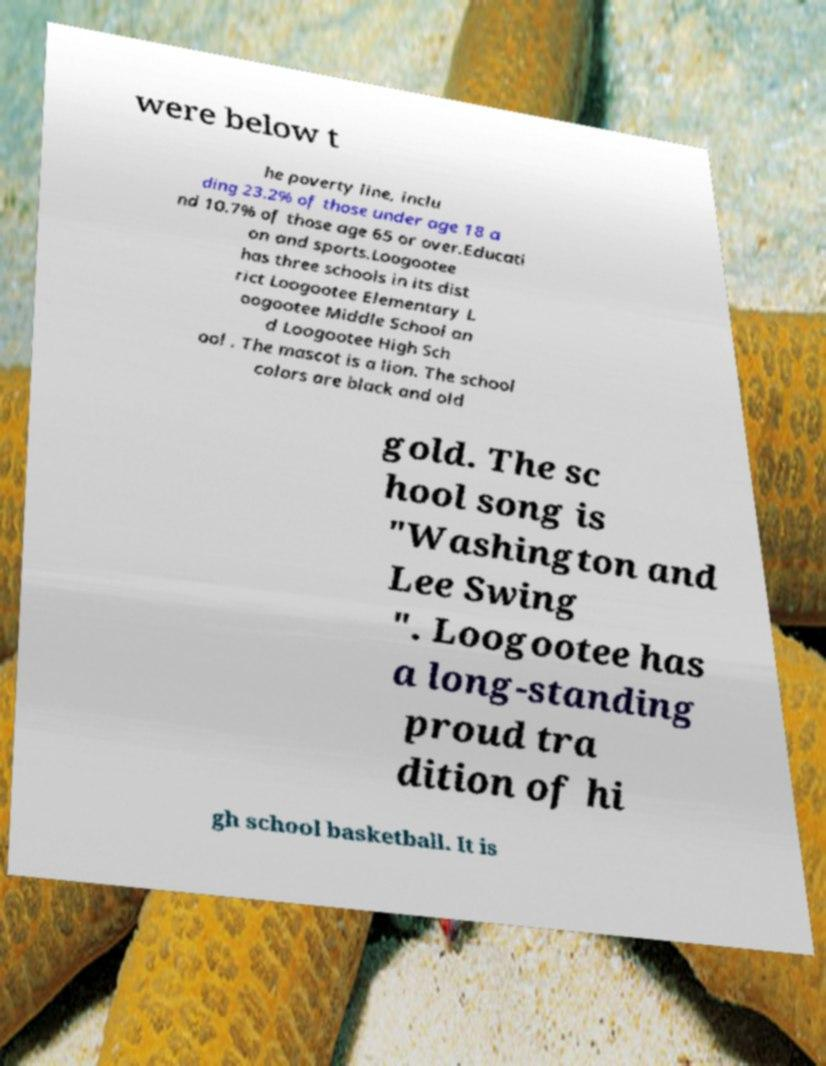I need the written content from this picture converted into text. Can you do that? were below t he poverty line, inclu ding 23.2% of those under age 18 a nd 10.7% of those age 65 or over.Educati on and sports.Loogootee has three schools in its dist rict Loogootee Elementary L oogootee Middle School an d Loogootee High Sch ool . The mascot is a lion. The school colors are black and old gold. The sc hool song is "Washington and Lee Swing ". Loogootee has a long-standing proud tra dition of hi gh school basketball. It is 